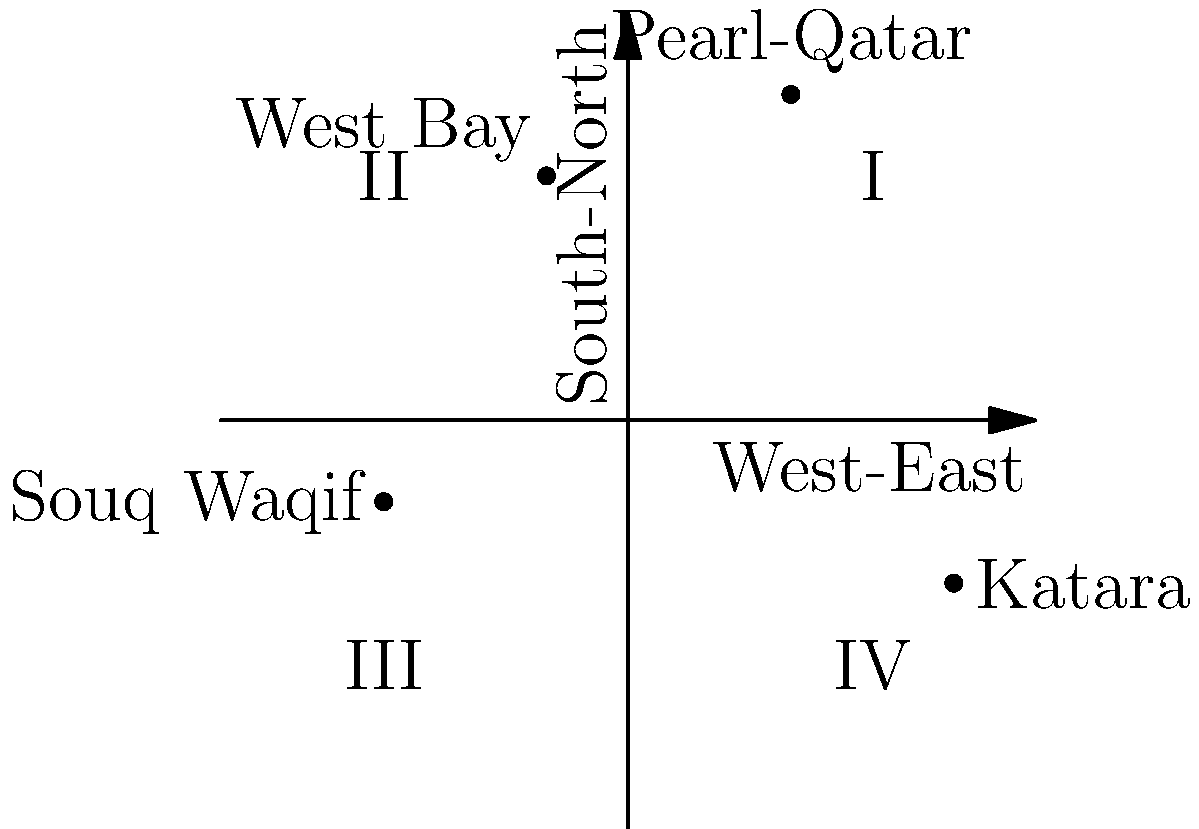On the Cartesian plane representing Doha's geography, with the origin at the city center, the x-axis representing West-East direction, and the y-axis representing South-North direction, identify the quadrant in which the popular cultural village Katara is located. To determine the quadrant of Katara on the given Cartesian plane, let's follow these steps:

1. Recall the quadrant definitions:
   - Quadrant I: Positive x, Positive y
   - Quadrant II: Negative x, Positive y
   - Quadrant III: Negative x, Negative y
   - Quadrant IV: Positive x, Negative y

2. Locate Katara on the plane: It is marked at coordinates $(4, -2)$.

3. Analyze the coordinates:
   - The x-coordinate (4) is positive, indicating it is east of the city center.
   - The y-coordinate (-2) is negative, indicating it is south of the city center.

4. Compare with quadrant definitions:
   - Positive x and negative y correspond to Quadrant IV.

Therefore, Katara is located in Quadrant IV of the Cartesian plane representing Doha's geography.
Answer: Quadrant IV 